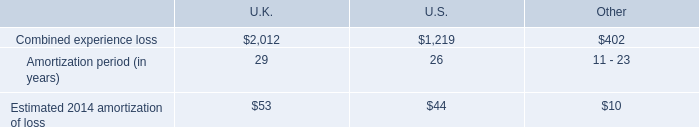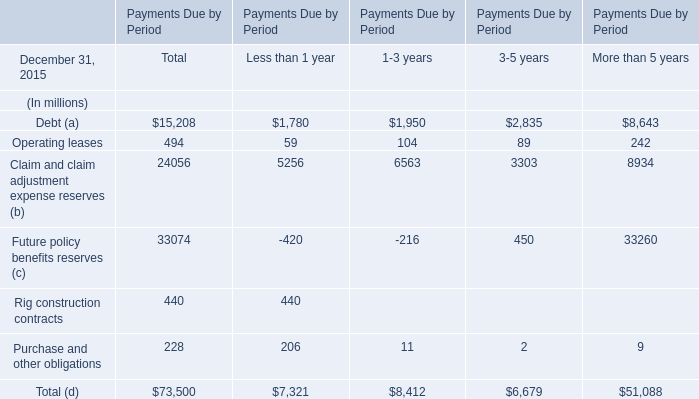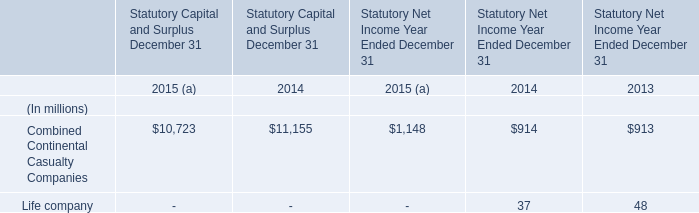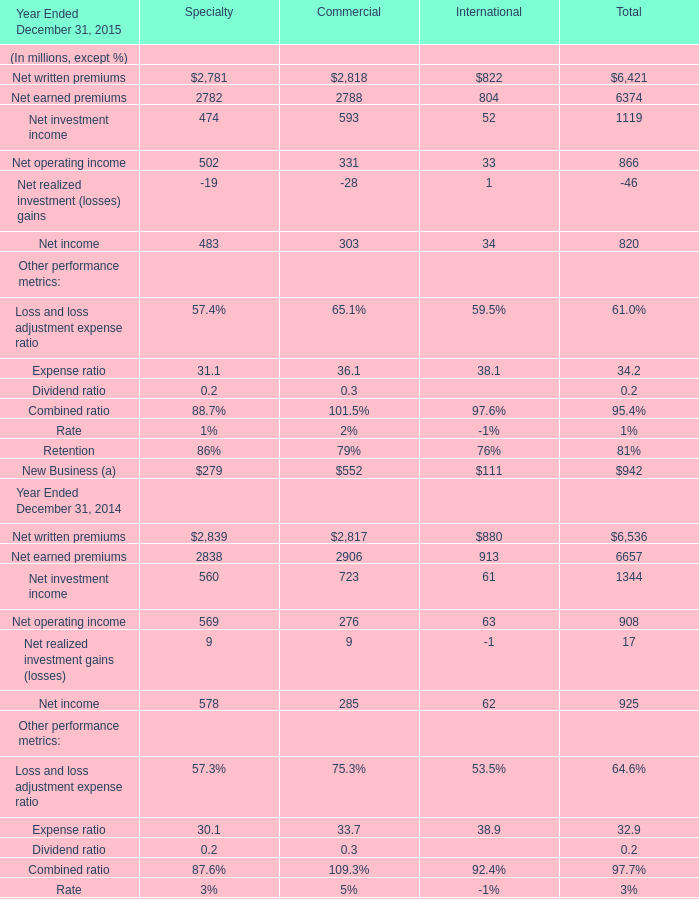What is the sum of Net written premiums, Net earned premiums and Net investment income for Total in 2015 ? (in million) 
Computations: ((6421 + 6374) + 1119)
Answer: 13914.0. 